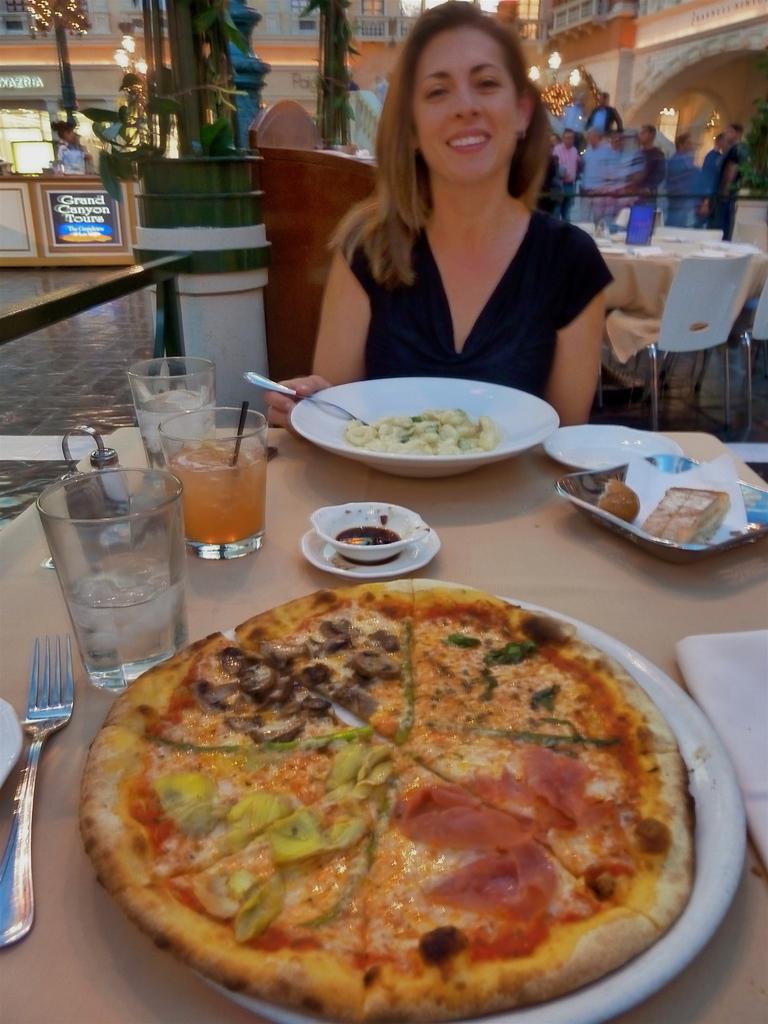Could you give a brief overview of what you see in this image? In this image I see a woman who is smiling and sitting, I can also see that she is holding a spoon and there is a table in front of her and there are 3 glasses, a fork and 3 plates in which there is food. In the background I see the buildings, few people and a table with chairs. 